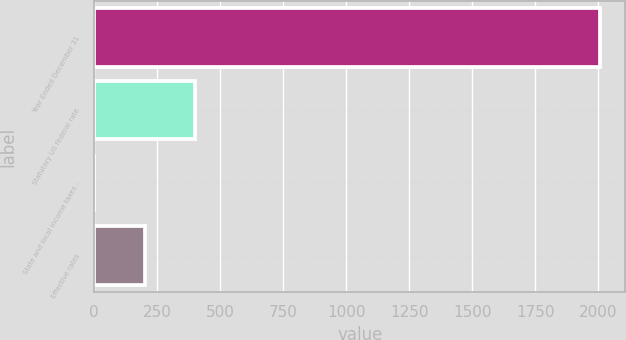Convert chart to OTSL. <chart><loc_0><loc_0><loc_500><loc_500><bar_chart><fcel>Year Ended December 31<fcel>Statutory US federal rate<fcel>State and local income taxes -<fcel>Effective rates<nl><fcel>2006<fcel>401.76<fcel>0.7<fcel>201.23<nl></chart> 